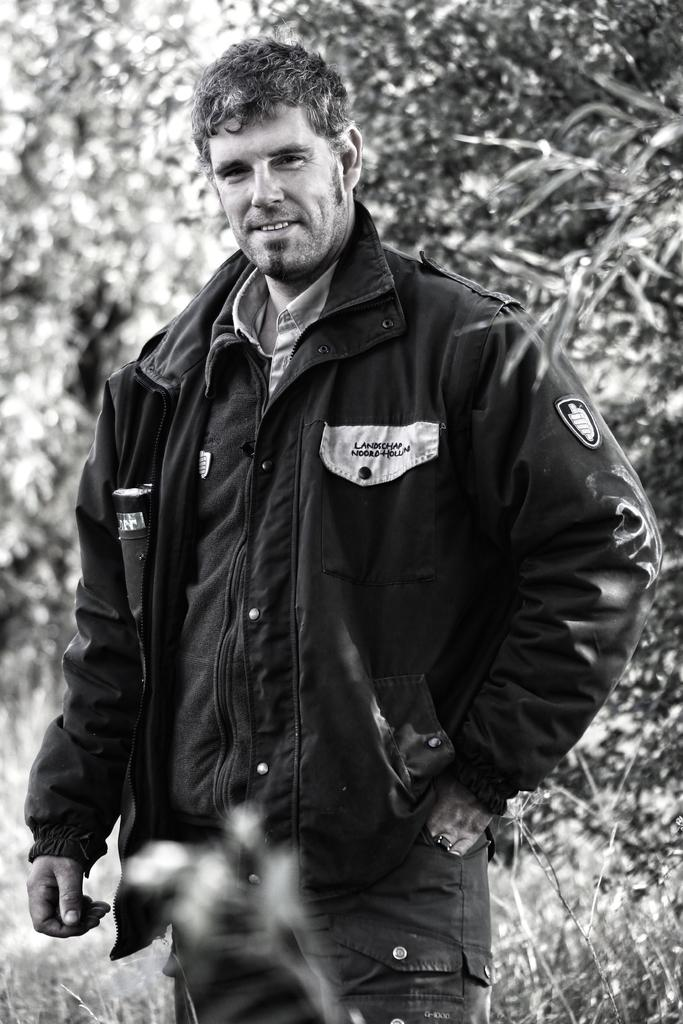What is the color scheme of the image? The image is in black and white. Who is the main subject in the image? There is a man in the center of the image. What is the man wearing? The man is wearing a jacket and jeans. What can be seen in the background of the image? There are trees in the background of the image. What type of birds can be seen playing in the image? There are no birds or any indication of playing in the image. 